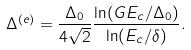Convert formula to latex. <formula><loc_0><loc_0><loc_500><loc_500>\Delta ^ { ( e ) } = \frac { \Delta _ { 0 } } { 4 \sqrt { 2 } } \frac { \ln ( G E _ { c } / \Delta _ { 0 } ) } { \ln ( E _ { c } / \delta ) } .</formula> 